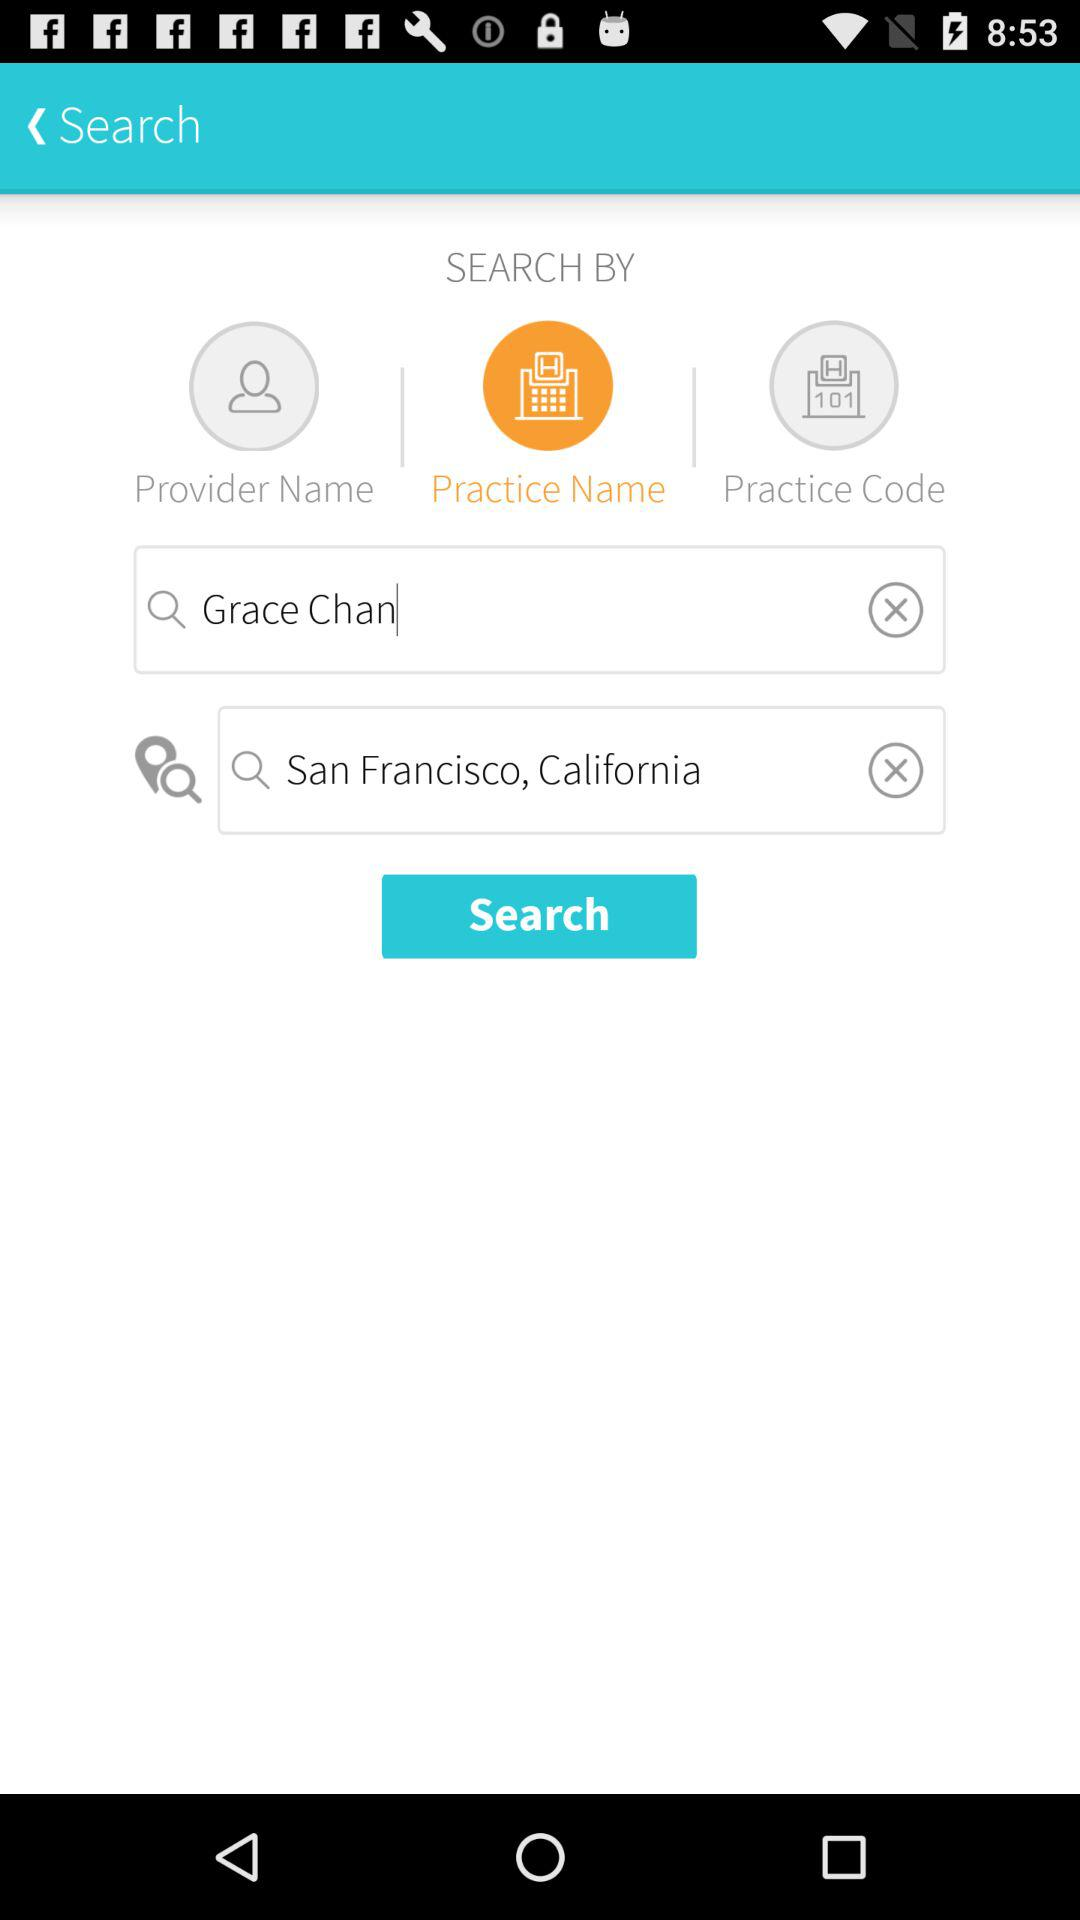What is the user name? The user name is Grace Chan. 